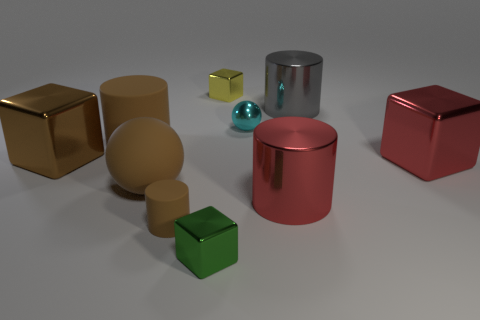Is the material of the gray thing the same as the large ball?
Make the answer very short. No. There is a red cylinder that is the same size as the gray metallic cylinder; what material is it?
Keep it short and to the point. Metal. How many things are big brown things that are to the right of the brown shiny object or big blocks?
Your answer should be very brief. 4. Are there an equal number of tiny cyan metal things that are right of the big red metallic cylinder and green matte balls?
Offer a very short reply. Yes. Is the color of the big ball the same as the small sphere?
Your answer should be very brief. No. The large cylinder that is both in front of the cyan sphere and behind the large brown metallic object is what color?
Offer a very short reply. Brown. How many spheres are either tiny brown things or large red objects?
Offer a terse response. 0. Is the number of brown metal blocks behind the tiny yellow metallic object less than the number of tiny cyan things?
Provide a succinct answer. Yes. There is a large brown object that is the same material as the tiny yellow thing; what is its shape?
Offer a terse response. Cube. What number of blocks are the same color as the rubber ball?
Ensure brevity in your answer.  1. 